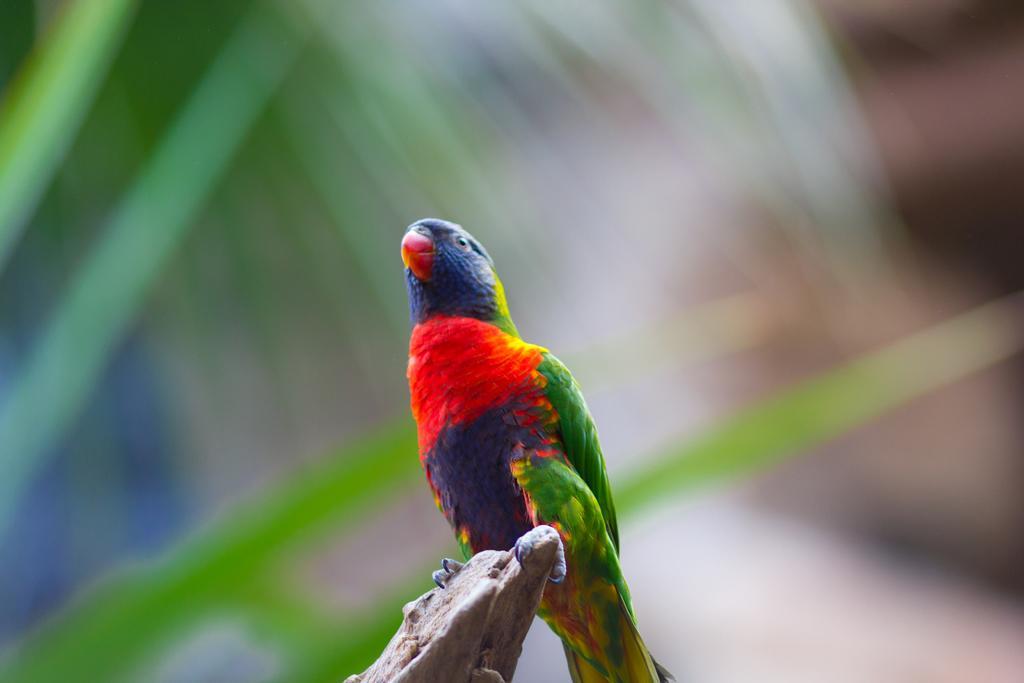Describe this image in one or two sentences. In this picture, we can see a bird on an object, we can see the blurred background. 